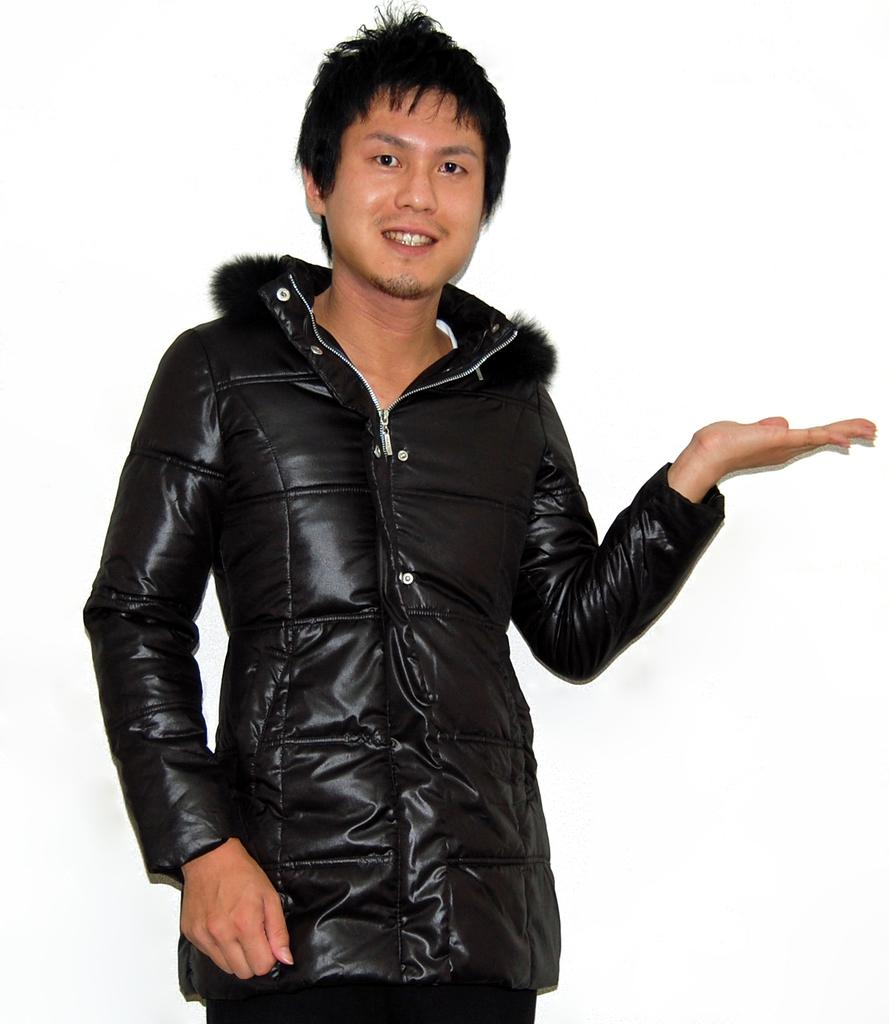What is the main subject of the image? The main subject of the image is a man. What is the man wearing in the image? The man is wearing a black jacket. What channel is the man watching on the television in the image? There is no television present in the image, so it is not possible to determine what channel the man might be watching. 